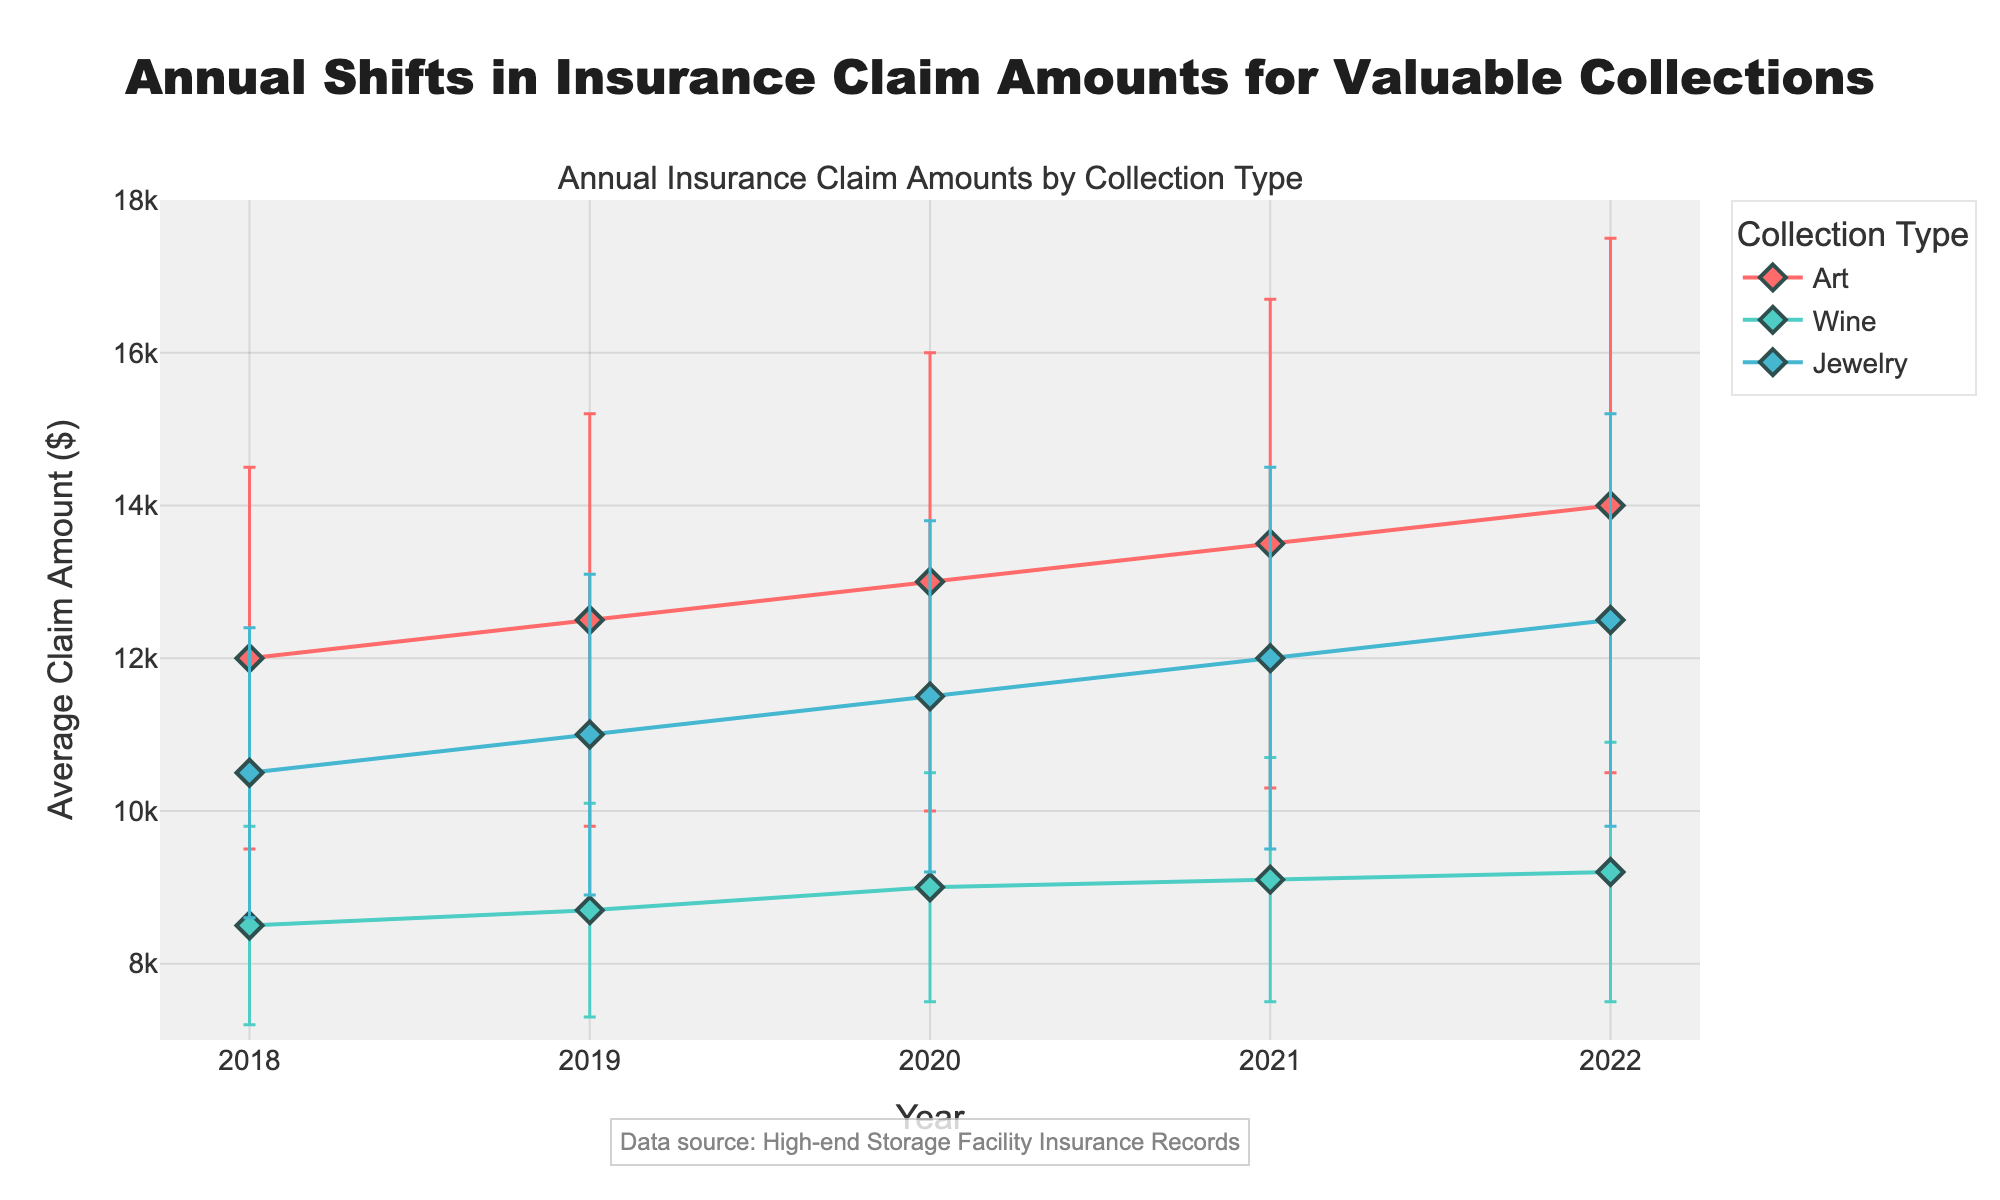what's the title of the plot? The title of the plot can be found at the top of the figure. It states that the plot shows the shifts in insurance claim amounts by collection type over several years.
Answer: Annual Shifts in Insurance Claim Amounts for Valuable Collections how many types of collections are displayed in the plot? The plot's legend shows the types of collections available. Three collection types are identified in the legend.
Answer: Three which collection type had the highest average claim amount in 2022? By examining the points on the y-axis for the year 2022, the highest average claim amount can be seen for "Art".
Answer: Art what are the y-axis range values in the plot? The y-axis range values can be seen on the y-axis itself, starting from the minimum and extending to the maximum value shown.
Answer: 7000 to 18000 how did the average claim amount for wine collections change from 2018 to 2022? To find this, look at the plot for Wine from the x-axis values corresponding to 2018 and 2022 and compare the y-axis values. The amount increased from 8500 in 2018 to 9200 in 2022.
Answer: Increased by 700 what year displayed the smallest average claim amount for jewelry collections? Trace the data points for Jewelry on the plot and identify the year with the lowest position on the y-axis. The smallest average claim amount was in 2018.
Answer: 2018 in which year did art collections have the maximum error bar range? Examine the error bars for Art collections across all the years shown in the plot and identify the year with the longest error bar.
Answer: 2022 what is the average claim amount difference between Art and Wine collections in 2022? First, find the y-values for both Art and Wine collections in 2022. Art is at 14000 and Wine is at 9200. Subtract Wine's value from Art's to get 14000 - 9200.
Answer: 4800 how do error bars help interpret the data in this plot? Error bars in the plot show the variability of the data around the average claim amounts, demonstrating the uncertainty and potential range for claims in each year for each type of collection.
Answer: Show variability and uncertainty do jewelry collections have a trend of increasing or decreasing claim amounts from 2018 to 2022? Observing the plotted trend line for Jewelry collections from 2018 to 2022, the data points appear to be increasing year after year.
Answer: Increasing 